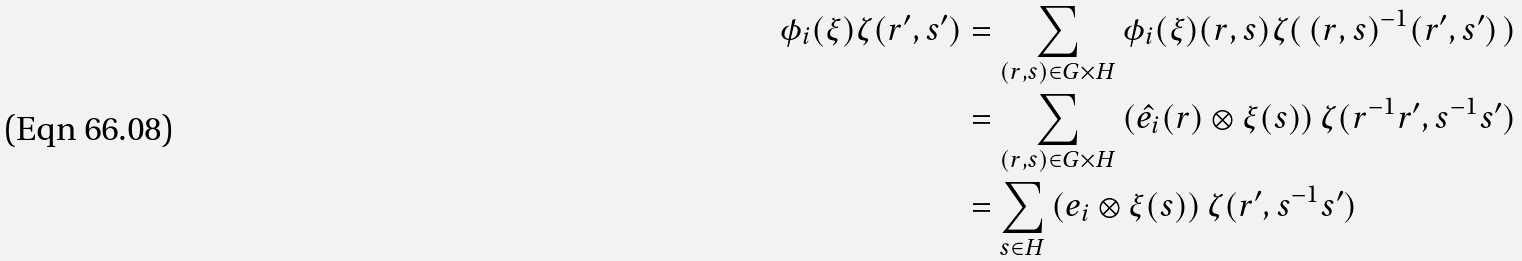Convert formula to latex. <formula><loc_0><loc_0><loc_500><loc_500>\phi _ { i } ( \xi ) \zeta ( r ^ { \prime } , s ^ { \prime } ) & = \sum _ { ( r , s ) \in G \times H } \phi _ { i } ( \xi ) ( r , s ) \zeta ( \, ( r , s ) ^ { - 1 } ( r ^ { \prime } , s ^ { \prime } ) \, ) \\ & = \sum _ { ( r , s ) \in G \times H } \left ( \hat { e _ { i } } ( r ) \otimes \xi ( s ) \right ) \zeta ( r ^ { - 1 } r ^ { \prime } , s ^ { - 1 } s ^ { \prime } ) \\ & = \sum _ { s \in H } \left ( e _ { i } \otimes \xi ( s ) \right ) \zeta ( r ^ { \prime } , s ^ { - 1 } s ^ { \prime } )</formula> 